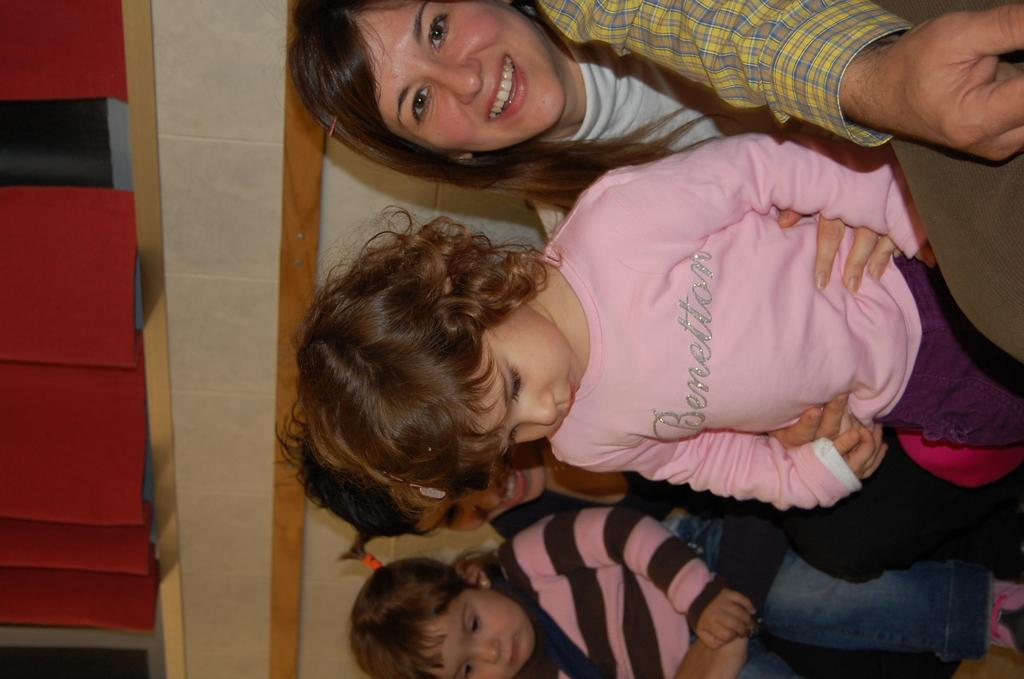How many kids are in the image? There are two kids in the center of the image. What are the people in the image doing? Three people are sitting in the image. Can you describe the expressions of the people in the image? Two of the people are smiling. What can be seen in the background of the image? There is a wall and curtains in the background of the image. How many kittens are playing with the fish on the foot in the image? There are no kittens, fish, or feet present in the image. 